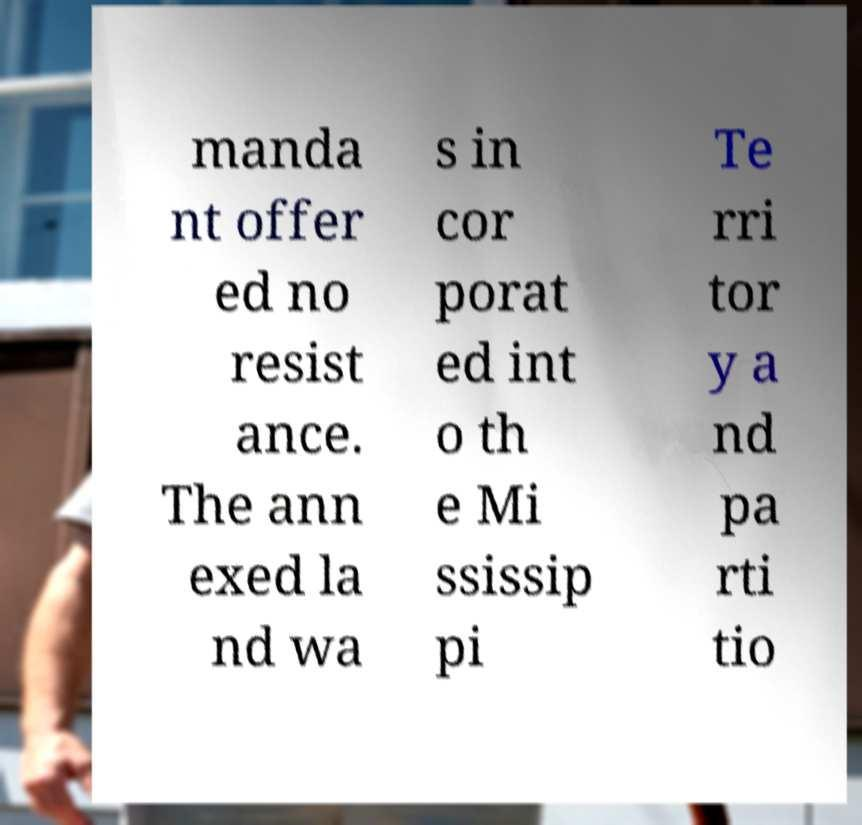Please identify and transcribe the text found in this image. manda nt offer ed no resist ance. The ann exed la nd wa s in cor porat ed int o th e Mi ssissip pi Te rri tor y a nd pa rti tio 